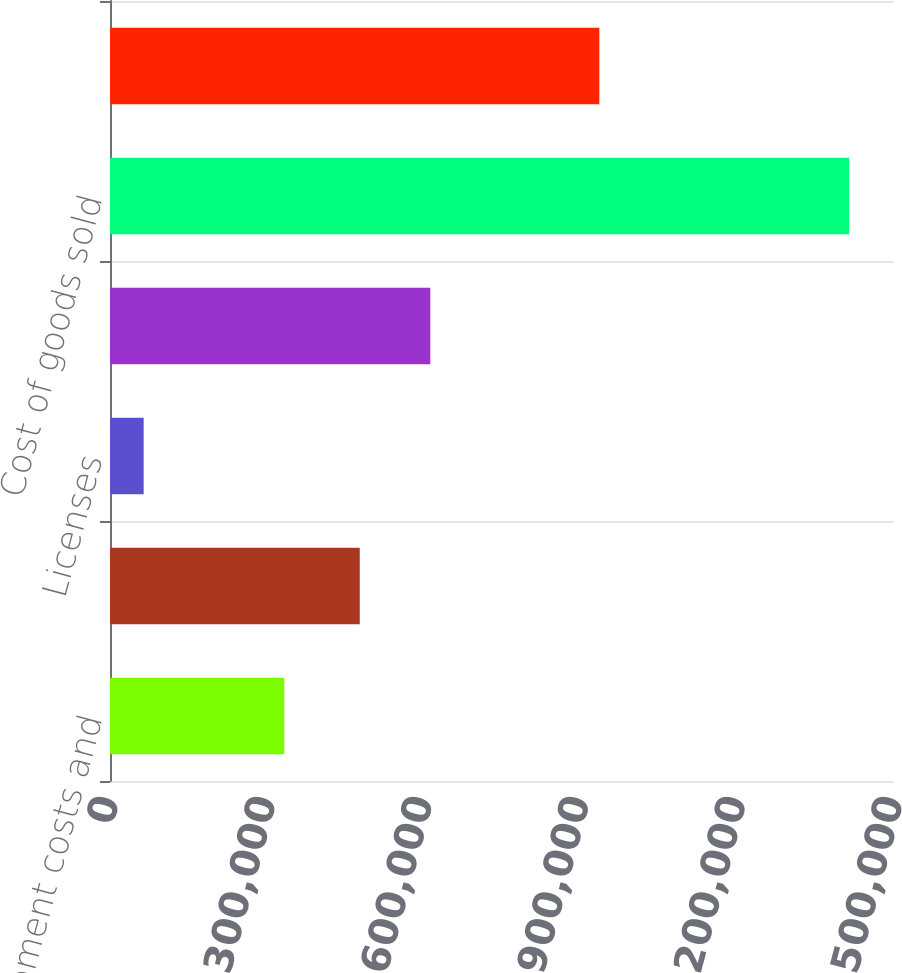Convert chart. <chart><loc_0><loc_0><loc_500><loc_500><bar_chart><fcel>Software development costs and<fcel>Product costs<fcel>Licenses<fcel>Internal royalties<fcel>Cost of goods sold<fcel>Gross profit<nl><fcel>333450<fcel>477861<fcel>64412<fcel>612852<fcel>1.41433e+06<fcel>936241<nl></chart> 